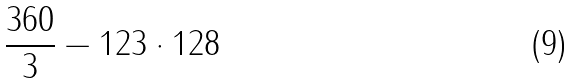<formula> <loc_0><loc_0><loc_500><loc_500>\frac { 3 6 0 } { 3 } - 1 2 3 \cdot 1 2 8</formula> 